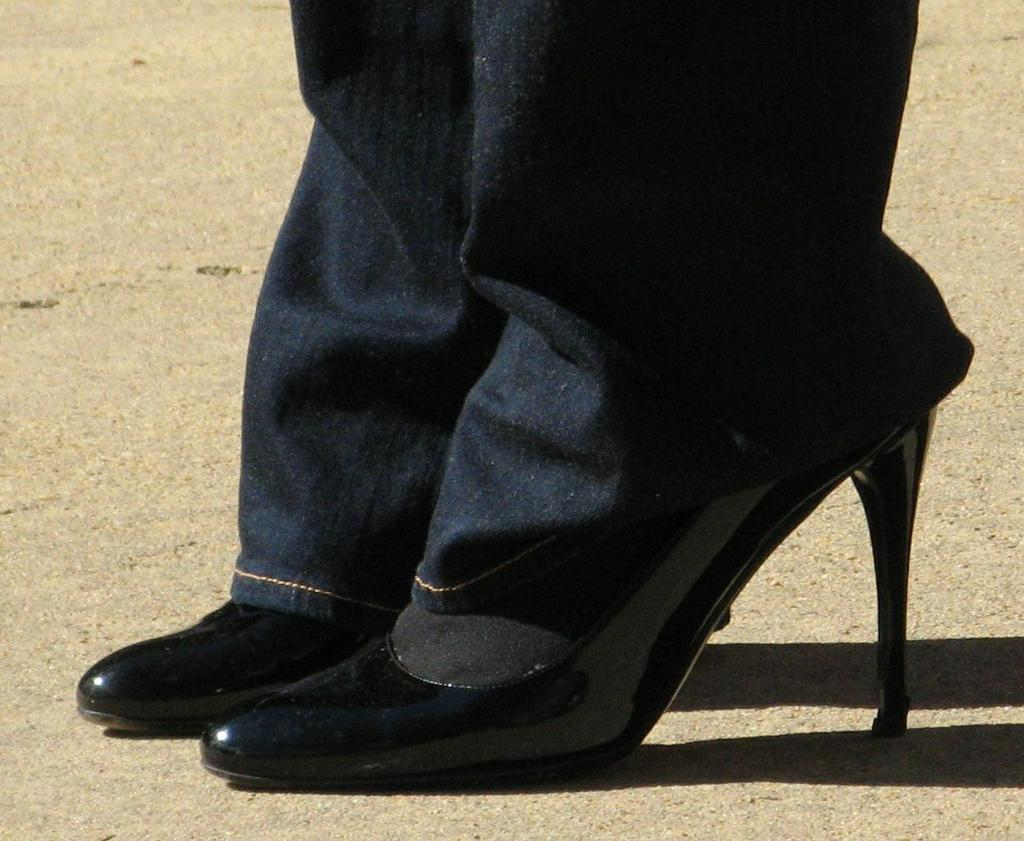Who or what is present in the image? There is a person in the image. What part of the person's body can be seen? The person's legs are visible. What type of footwear is the person wearing? The person is wearing black color shoes. What is the person's temper like in the image? The person's temper cannot be determined from the image, as it only shows their legs and shoes. 